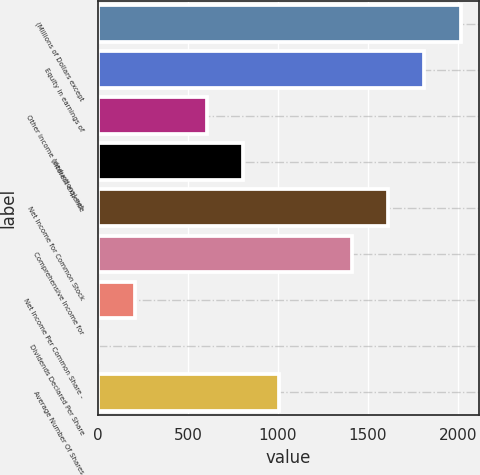Convert chart. <chart><loc_0><loc_0><loc_500><loc_500><bar_chart><fcel>(Millions of Dollars except<fcel>Equity in earnings of<fcel>Other income (deductions) net<fcel>Interest expense<fcel>Net Income for Common Stock<fcel>Comprehensive Income for<fcel>Net Income Per Common Share -<fcel>Dividends Declared Per Share<fcel>Average Number Of Shares<nl><fcel>2014.02<fcel>1812.87<fcel>605.97<fcel>807.12<fcel>1611.72<fcel>1410.57<fcel>203.67<fcel>2.52<fcel>1008.27<nl></chart> 